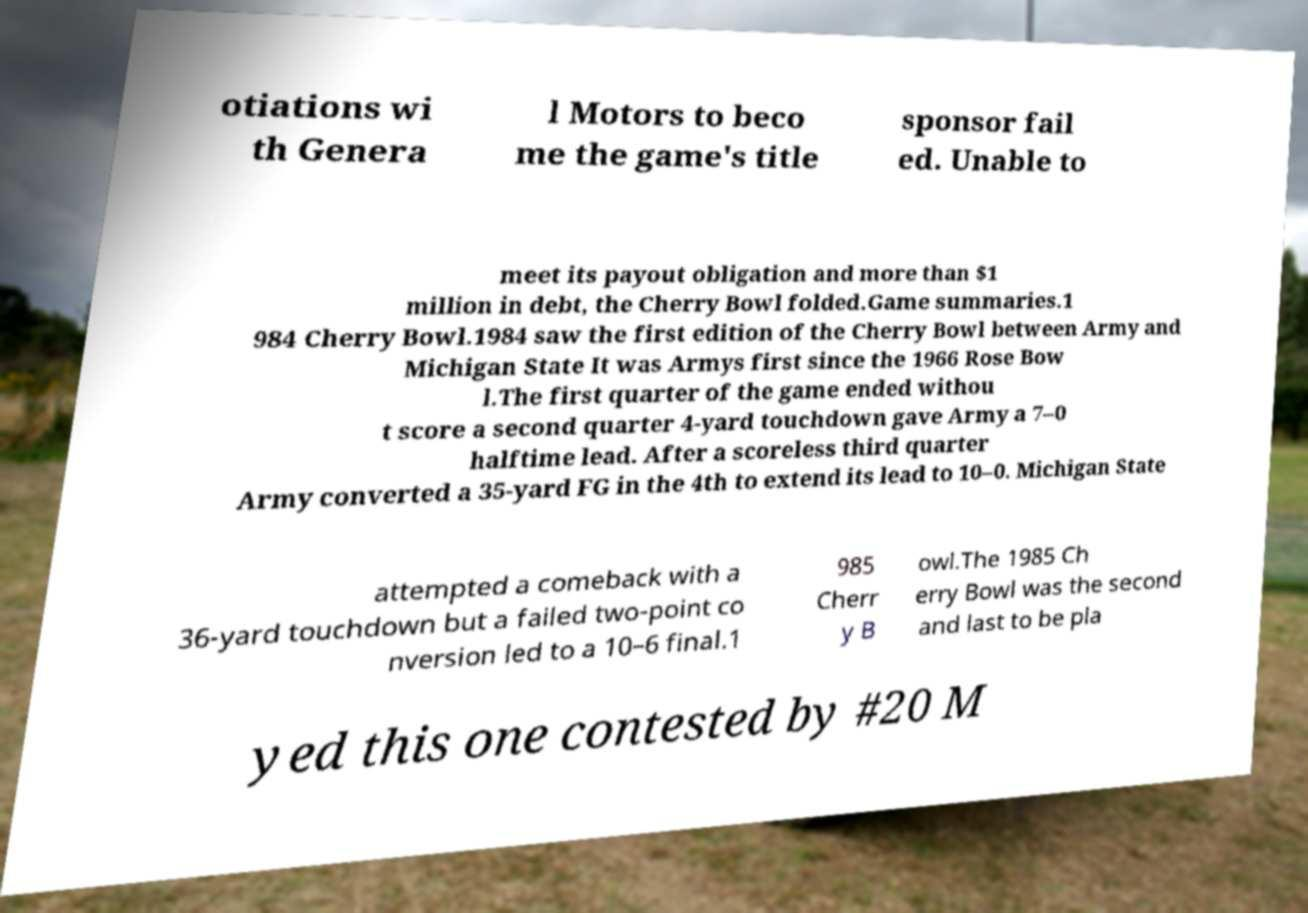Please identify and transcribe the text found in this image. otiations wi th Genera l Motors to beco me the game's title sponsor fail ed. Unable to meet its payout obligation and more than $1 million in debt, the Cherry Bowl folded.Game summaries.1 984 Cherry Bowl.1984 saw the first edition of the Cherry Bowl between Army and Michigan State It was Armys first since the 1966 Rose Bow l.The first quarter of the game ended withou t score a second quarter 4-yard touchdown gave Army a 7–0 halftime lead. After a scoreless third quarter Army converted a 35-yard FG in the 4th to extend its lead to 10–0. Michigan State attempted a comeback with a 36-yard touchdown but a failed two-point co nversion led to a 10–6 final.1 985 Cherr y B owl.The 1985 Ch erry Bowl was the second and last to be pla yed this one contested by #20 M 